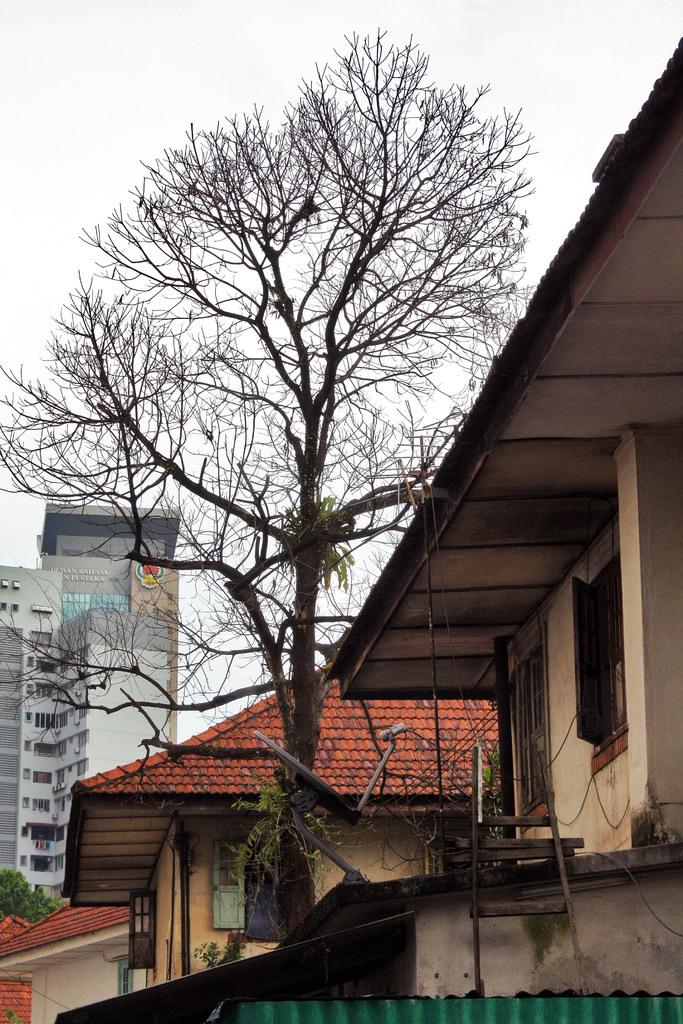What type of structures can be seen in the image? There are buildings in the image. What part of the buildings is visible in the image? Rooftops are visible in the image. What architectural features can be seen on the buildings? There are windows in the image. What type of natural elements are present in the image? Trees are present in the image. What else can be seen in the image besides buildings and trees? There are objects in the image. What is visible in the background of the image? The sky is visible in the background of the image. Where is the board located in the image? There is a board on a wall in the image. How does the humor affect the fog in the image? There is no fog or humor present in the image. What type of bag is hanging from the board on the wall? There is no bag present in the image; only a board on a wall is mentioned. 